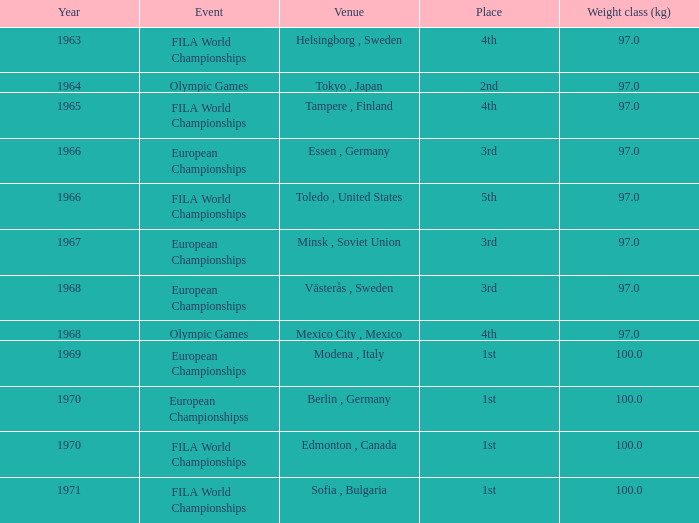When was the first year that edmonton, canada hosted a competition with a weight category exceeding 100 kg? None. 